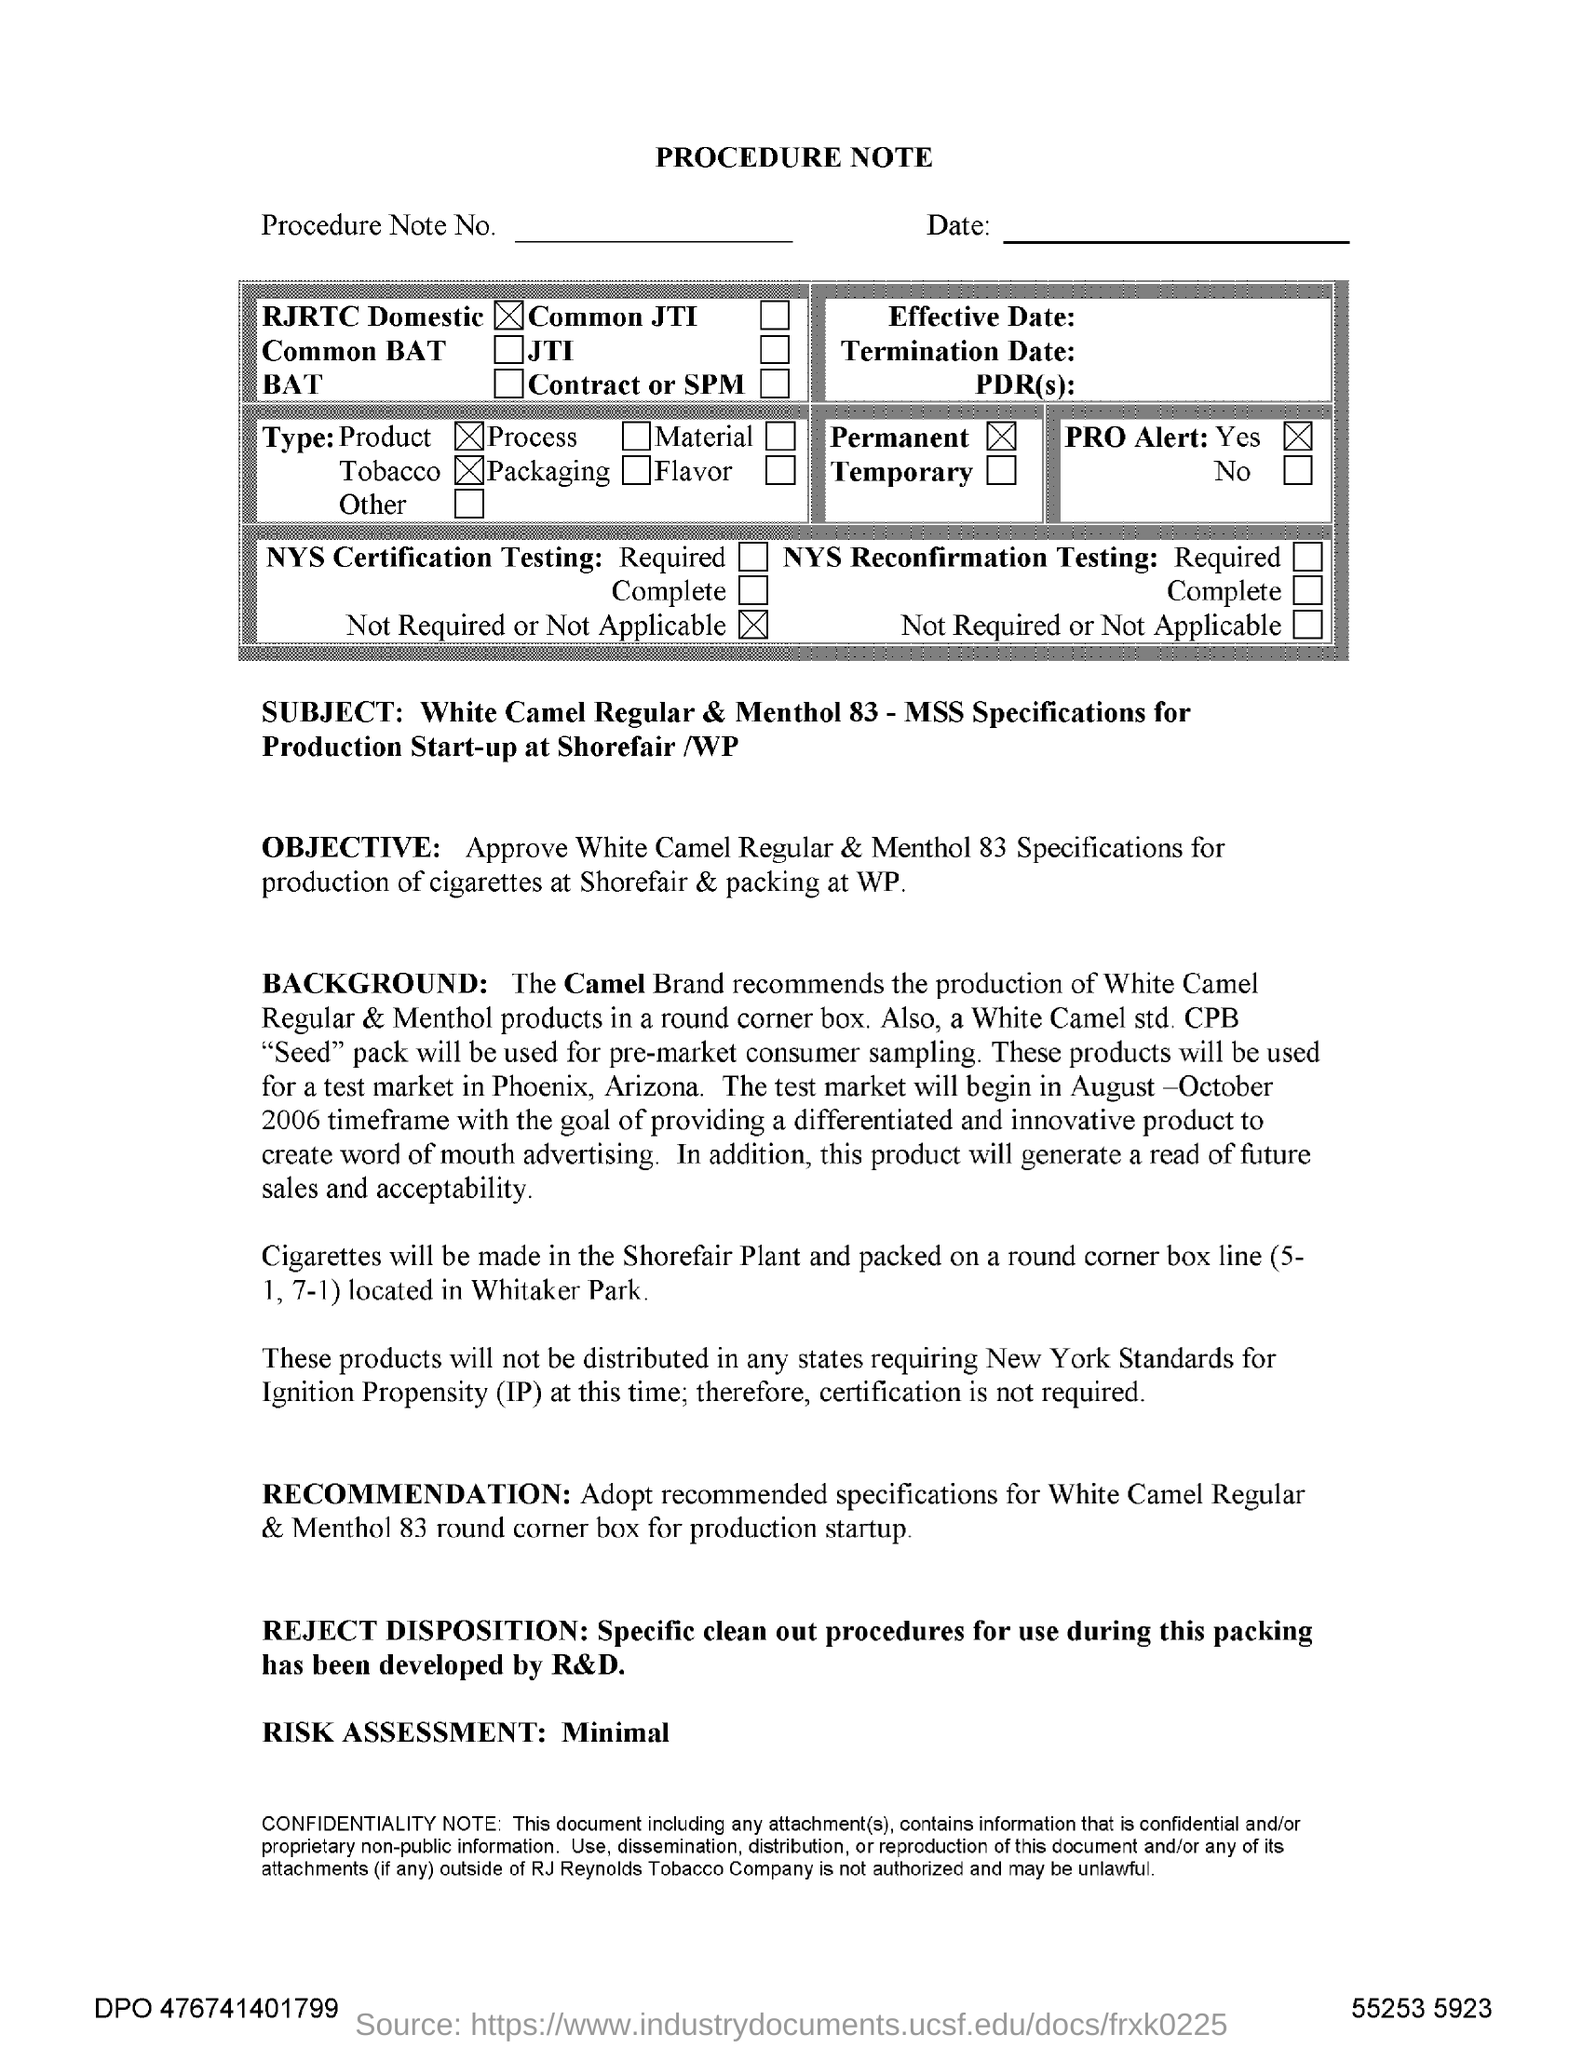What is the subject mentioned in the procedure note?
Ensure brevity in your answer.  White camel regular & menthol 83 - mss specifications for production start-up at shorefair /wp. What is the fullform of IP?
Provide a succinct answer. Ignititon Propensity. 